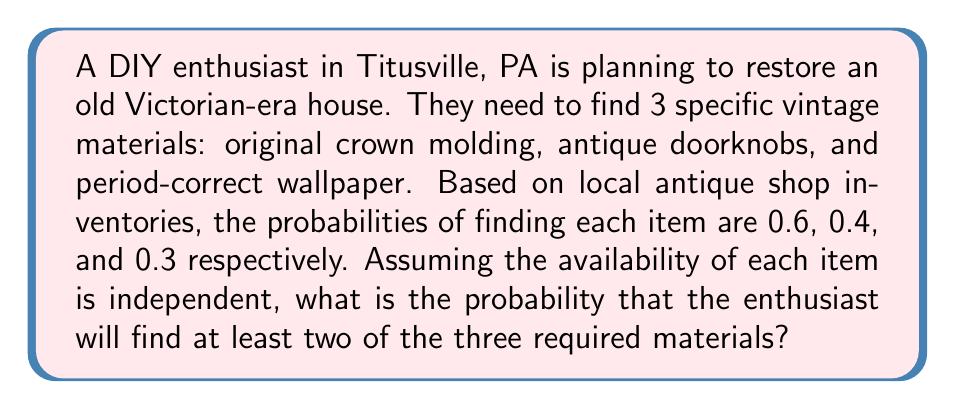Could you help me with this problem? Let's approach this step-by-step:

1) First, we need to calculate the probability of finding at least two items. It's easier to calculate this by subtracting the probability of finding zero or one item from 1.

2) Let's define events:
   A: finding crown molding (P(A) = 0.6)
   B: finding antique doorknobs (P(B) = 0.4)
   C: finding period-correct wallpaper (P(C) = 0.3)

3) Probability of finding zero items:
   P(none) = (1-0.6)(1-0.4)(1-0.3) = 0.4 * 0.6 * 0.7 = 0.168

4) Probability of finding exactly one item:
   P(only A) = 0.6 * (1-0.4) * (1-0.3) = 0.6 * 0.6 * 0.7 = 0.252
   P(only B) = (1-0.6) * 0.4 * (1-0.3) = 0.4 * 0.4 * 0.7 = 0.112
   P(only C) = (1-0.6) * (1-0.4) * 0.3 = 0.4 * 0.6 * 0.3 = 0.072
   
   P(exactly one) = 0.252 + 0.112 + 0.072 = 0.436

5) Probability of finding at least two items:
   P(at least two) = 1 - P(none) - P(exactly one)
                   = 1 - 0.168 - 0.436
                   = 0.396

Therefore, the probability of finding at least two of the three required materials is 0.396 or 39.6%.
Answer: 0.396 